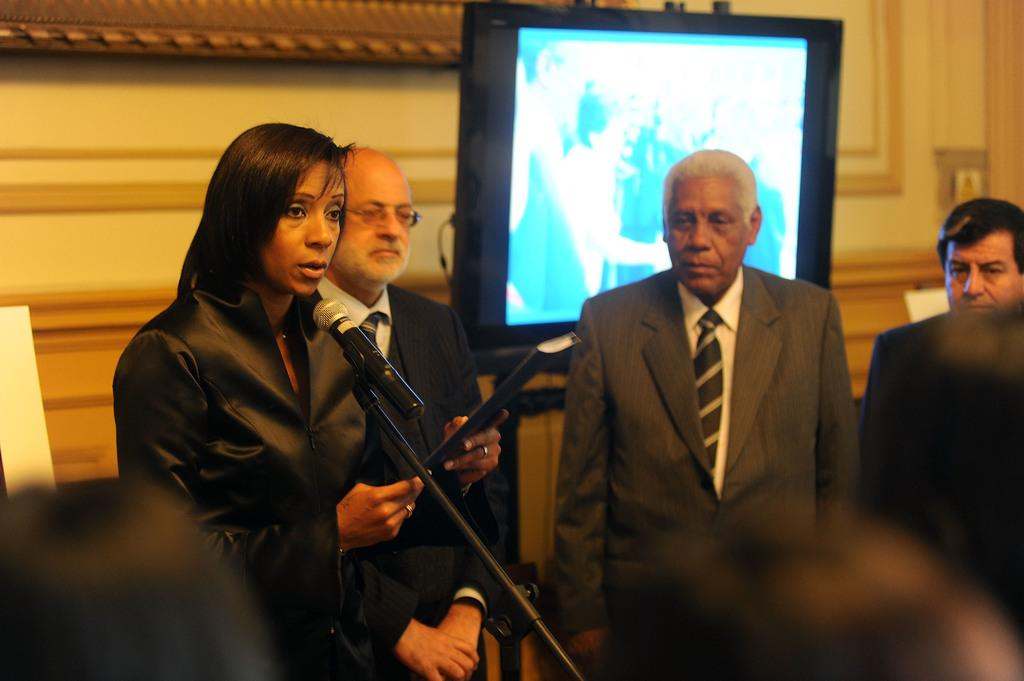What can be observed about the people in the image? There are people standing in the image. Can you describe the woman in the image? The woman is standing in front of a mic. What is visible in the background of the image? There is a television and a wall in the background of the image. What type of salt is being stored in the crate next to the woman? There is no crate or salt present in the image. What valuable jewel is the woman holding in her hand? The woman is not holding any jewel in her hand; she is standing in front of a mic. 